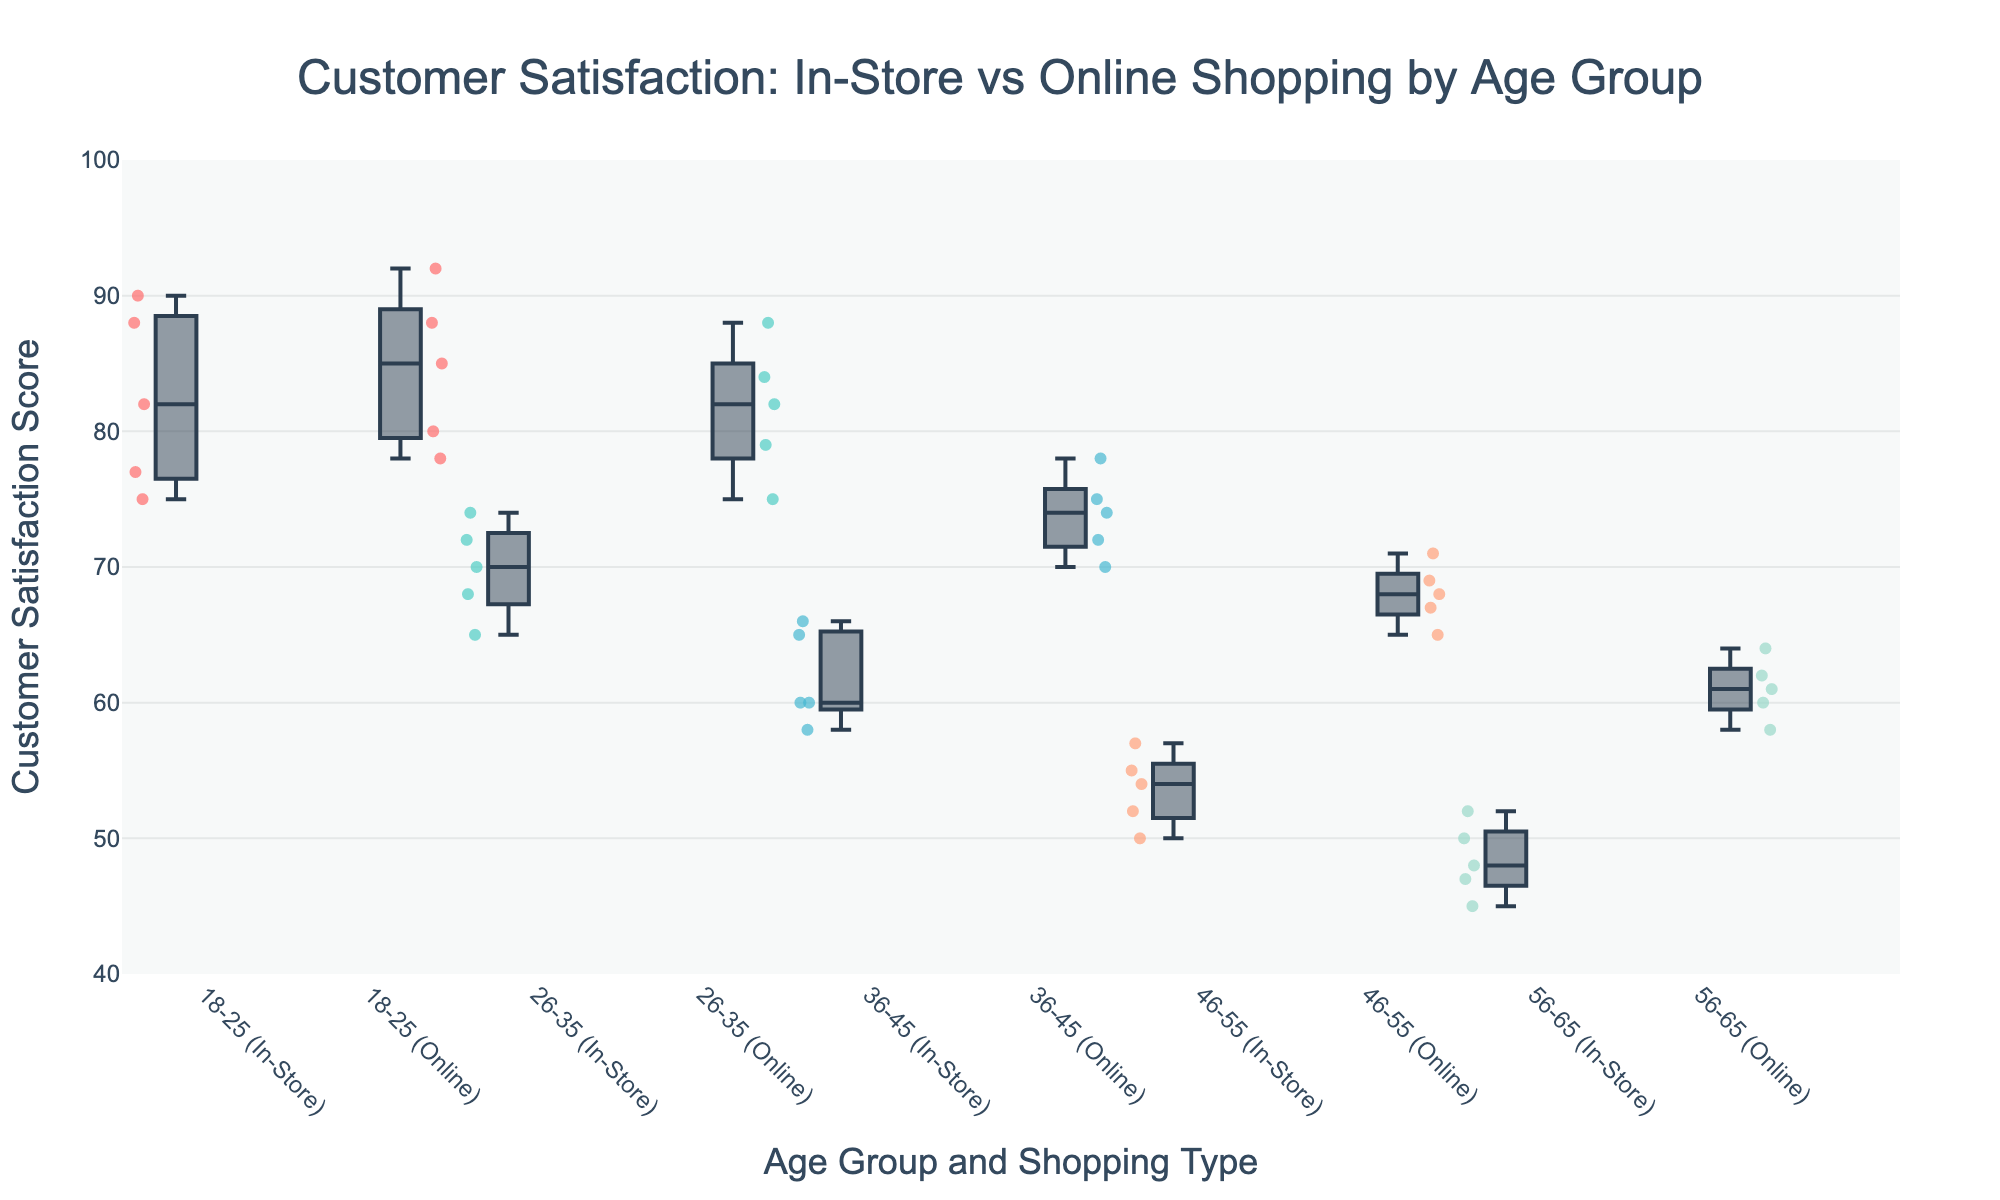what is the title of the figure? The title is typically located at the top of the figure and is usually the most prominent text. In this case, it should summarize the content, indicating a comparison of customer satisfaction between in-store and online shopping by age group.
Answer: Customer Satisfaction: In-Store vs Online Shopping by Age Group What age group has the highest median customer satisfaction score for online shopping? To find the median customer satisfaction score for online shopping, look at the middle line of the boxplot for each age group for the "Online" category. Compare these medians across the age groups to find the highest one.
Answer: 18-25 Which shopping type generally has higher customer satisfaction scores across all age groups? To determine this, compare the spread and position of the box plots for both in-store and online shopping across all age groups. Noting the medians and the range of scores helps in identifying which shopping type has overall higher scores.
Answer: Online For the 36-45 age group, how does the median customer satisfaction score for in-store shopping compare to that of online shopping? Identify the median lines in the box plots for both in-store and online shopping within the 36-45 age group. Determine if the line is higher or lower for in-store compared to online.
Answer: Lower What is the range of customer satisfaction scores for in-store shopping in the 56-65 age group? The range of customer satisfaction scores can be determined by subtracting the minimum value from the maximum value within the in-store box plot for the 56-65 age group.
Answer: 48-45 = 3 Which age group has the largest interquartile range (IQR) for in-store shopping scores? To find the IQR, look at the length of the box (which represents the middle 50% of the data) for each age group under the in-store category. The largest box represents the largest IQR.
Answer: 18-25 Is there an age group where customer satisfaction scores for in-store shopping and online shopping are almost similar? Examine the medians and the spread of the box plots for both in-store and online shopping for each age group to identify if one group's scores are close to each other.
Answer: 18-25 In the 46-55 age group, what is the approximate difference in median customer satisfaction scores between in-store and online shopping? Identify the median points on the box plots for both in-store and online shopping in the 46-55 age group and calculate the difference between these two values.
Answer: 65-54 = 11 Which shopping type has a wider range of satisfaction scores for the 26-35 age group? Compare the range (difference between the minimum and maximum values) of the satisfaction scores for both in-store and online shopping within the 26-35 age group.
Answer: Online For which age group is the median satisfaction score for in-store shopping the lowest? Identify the middle line of the box plot for in-store shopping for each age group and find which one has the lowest position.
Answer: 56-65 